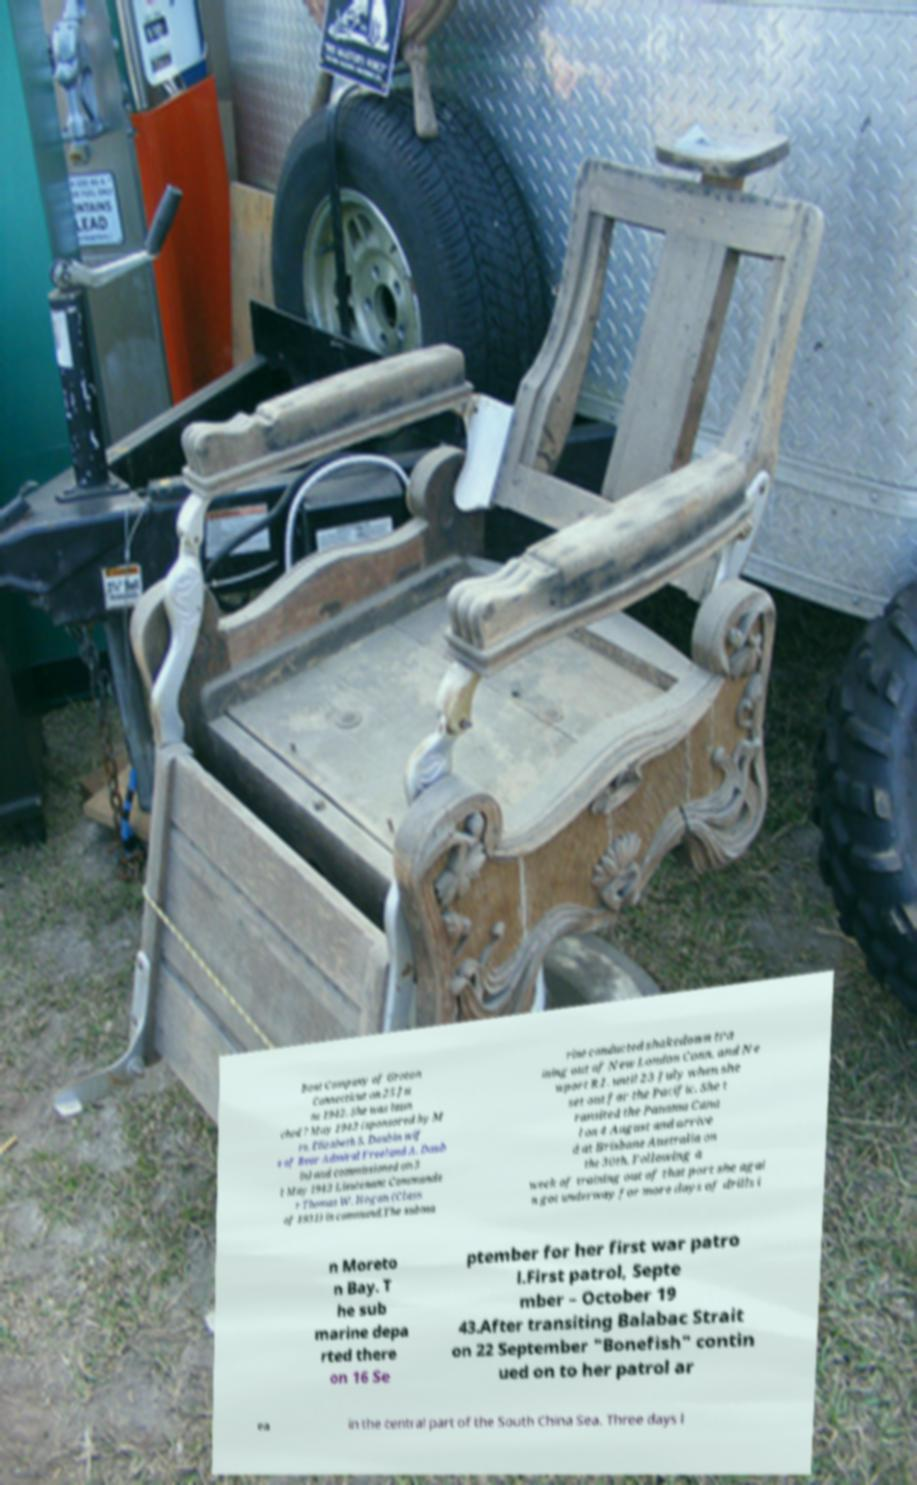Could you assist in decoding the text presented in this image and type it out clearly? Boat Company of Groton Connecticut on 25 Ju ne 1942. She was laun ched 7 May 1943 (sponsored by M rs. Elizabeth S. Daubin wif e of Rear Admiral Freeland A. Daub in) and commissioned on 3 1 May 1943 Lieutenant Commande r Thomas W. Hogan (Class of 1931) in command.The subma rine conducted shakedown tra ining out of New London Conn. and Ne wport R.I. until 23 July when she set out for the Pacific. She t ransited the Panama Cana l on 4 August and arrive d at Brisbane Australia on the 30th. Following a week of training out of that port she agai n got underway for more days of drills i n Moreto n Bay. T he sub marine depa rted there on 16 Se ptember for her first war patro l.First patrol, Septe mber – October 19 43.After transiting Balabac Strait on 22 September "Bonefish" contin ued on to her patrol ar ea in the central part of the South China Sea. Three days l 